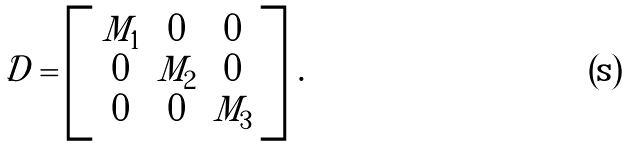<formula> <loc_0><loc_0><loc_500><loc_500>\mathcal { D } = \left [ \begin{array} { c c c } M _ { 1 } & 0 & 0 \\ 0 & M _ { 2 } & 0 \\ 0 & 0 & M _ { 3 } \end{array} \right ] \, .</formula> 